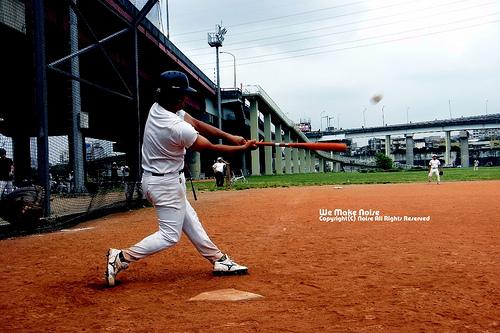Who is playing?
Concise answer only. Batter. Did he hit the ball?
Answer briefly. Yes. Are is pants dirty?
Be succinct. Yes. 